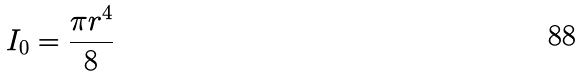<formula> <loc_0><loc_0><loc_500><loc_500>I _ { 0 } = \frac { \pi r ^ { 4 } } { 8 }</formula> 